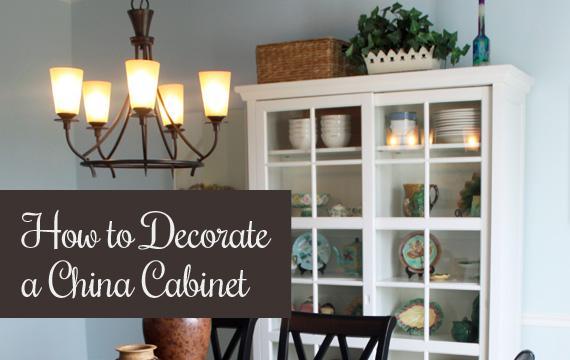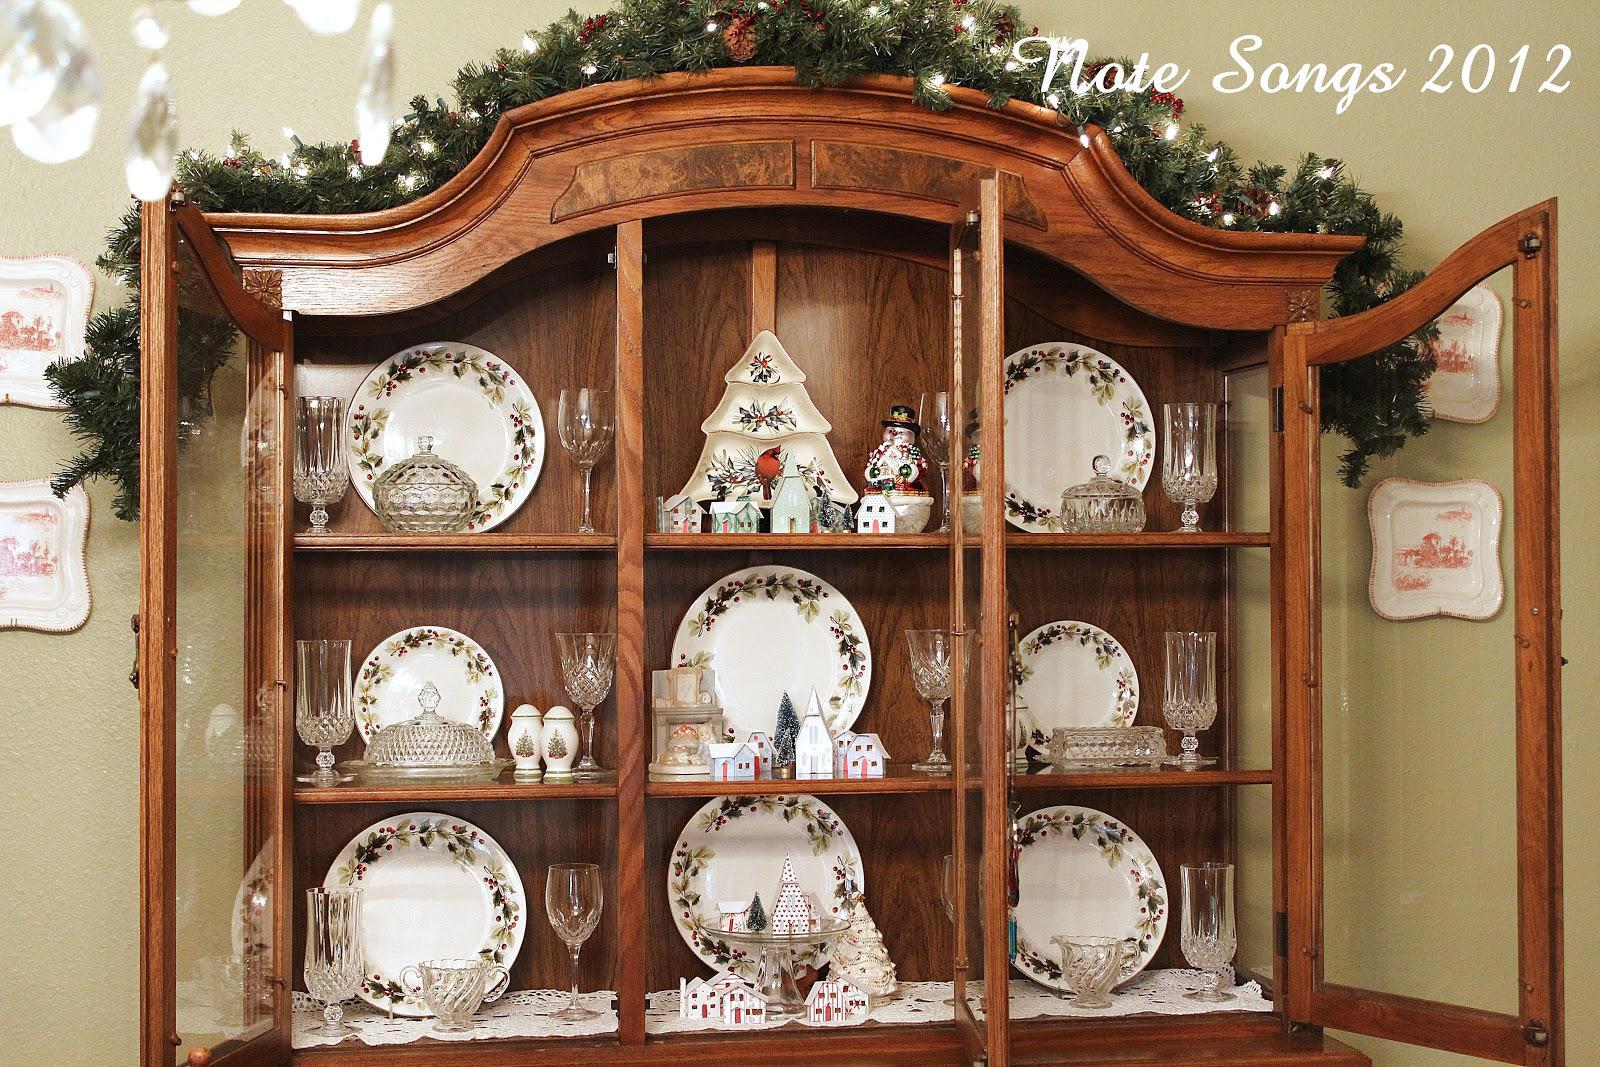The first image is the image on the left, the second image is the image on the right. Assess this claim about the two images: "One of the cabinets containing dishes is brown.". Correct or not? Answer yes or no. Yes. The first image is the image on the left, the second image is the image on the right. Evaluate the accuracy of this statement regarding the images: "An image shows a brown cabinet with an arched top and open doors.". Is it true? Answer yes or no. Yes. 